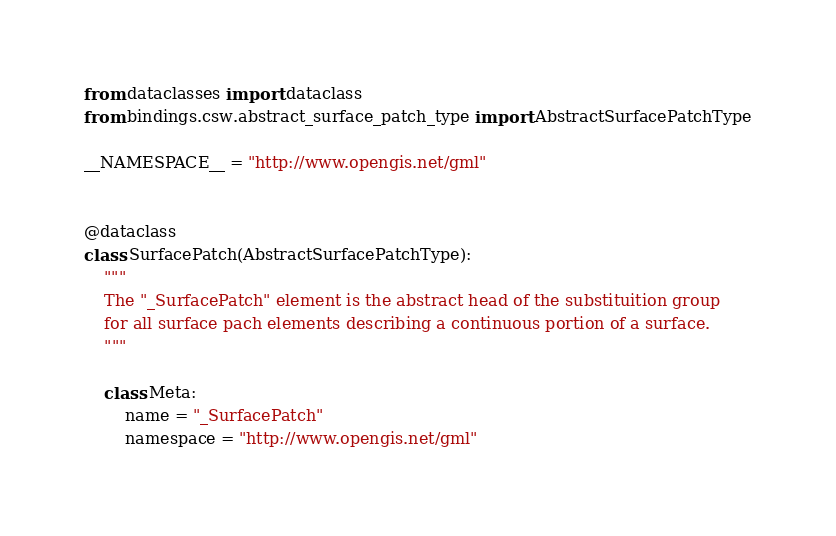<code> <loc_0><loc_0><loc_500><loc_500><_Python_>from dataclasses import dataclass
from bindings.csw.abstract_surface_patch_type import AbstractSurfacePatchType

__NAMESPACE__ = "http://www.opengis.net/gml"


@dataclass
class SurfacePatch(AbstractSurfacePatchType):
    """
    The "_SurfacePatch" element is the abstract head of the substituition group
    for all surface pach elements describing a continuous portion of a surface.
    """

    class Meta:
        name = "_SurfacePatch"
        namespace = "http://www.opengis.net/gml"
</code> 